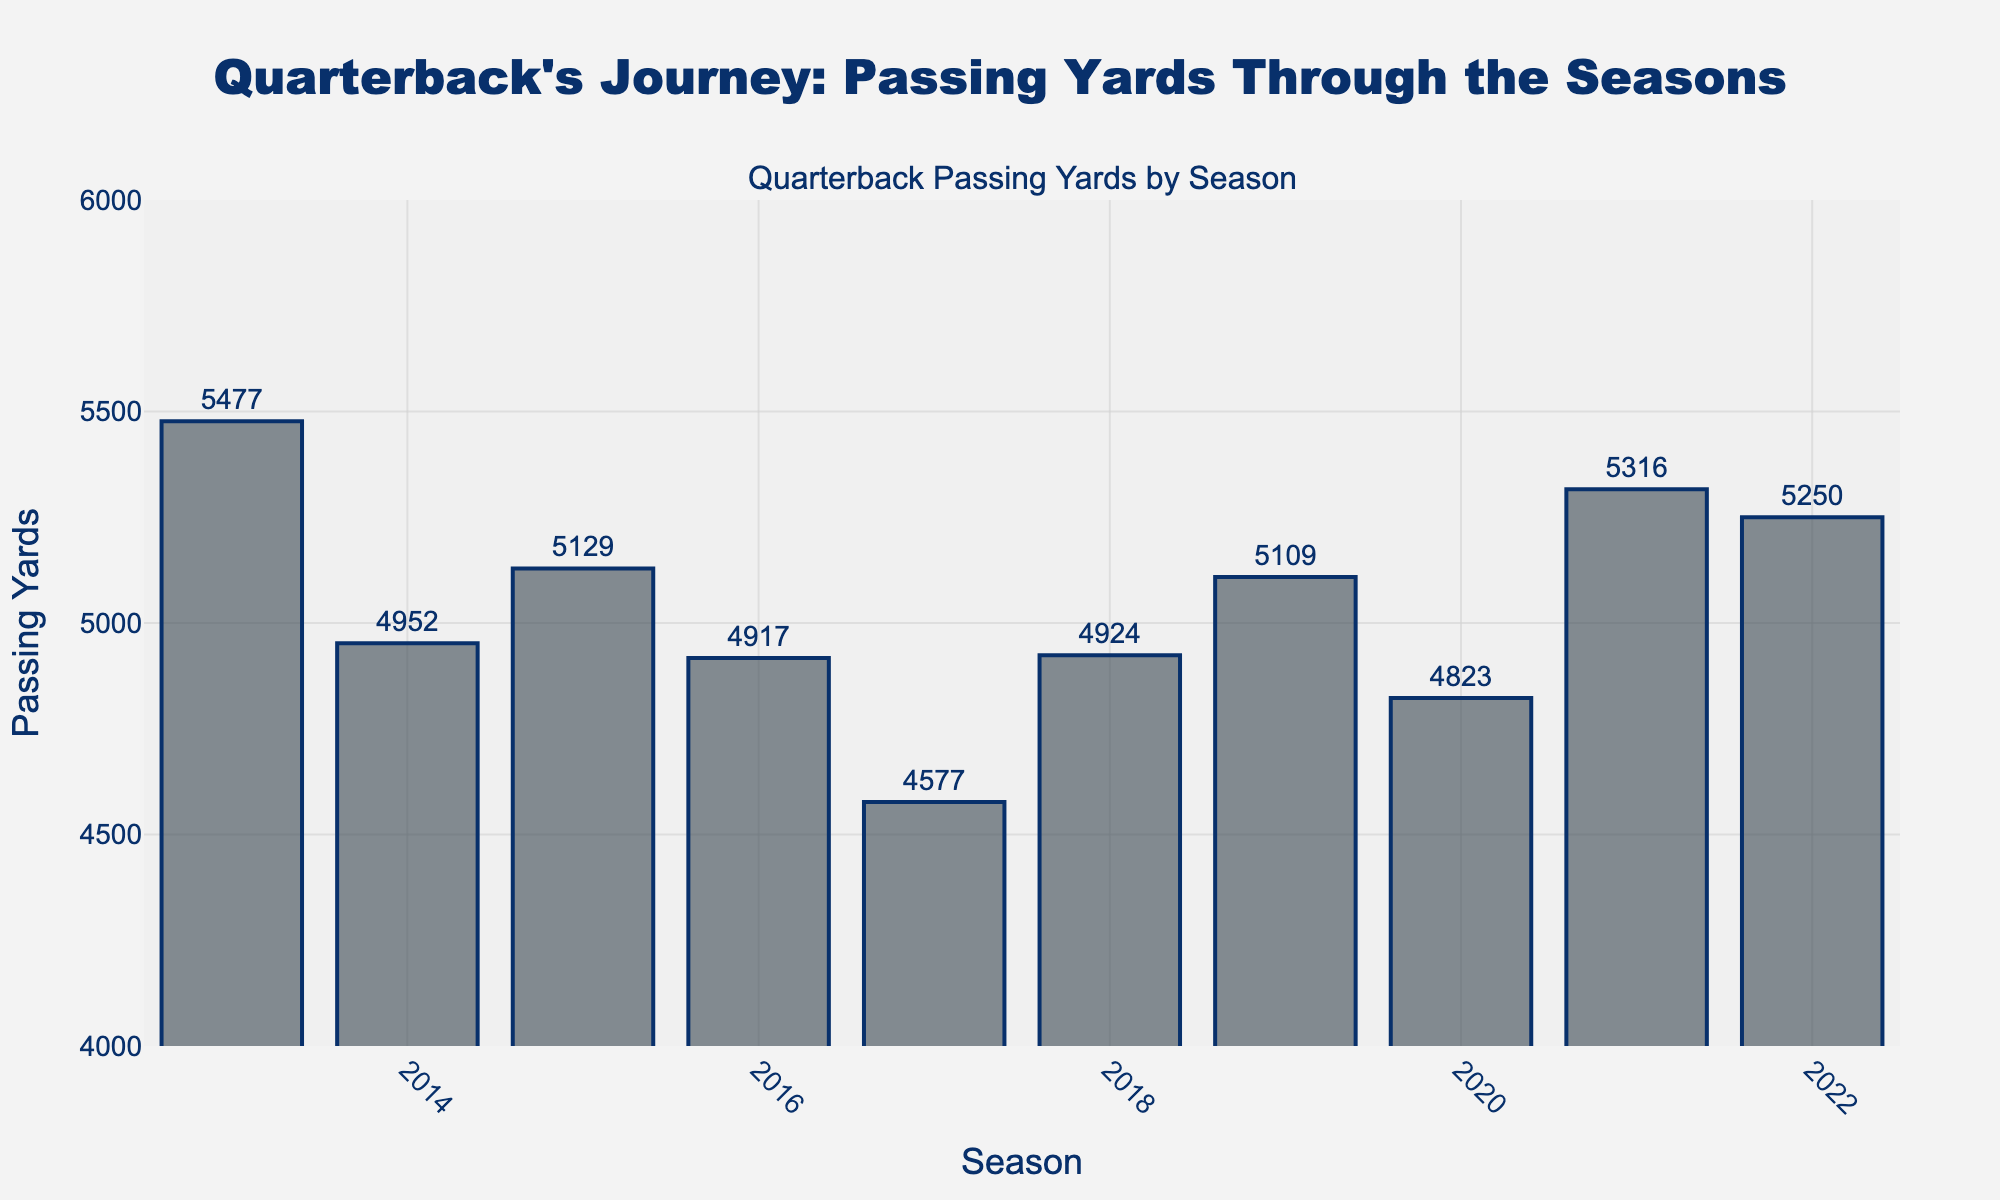Which season had the highest passing yards? The season with the highest passing yards can be identified by finding the tallest bar on the chart. The 2013 season has the highest passing yards, with a value of 5477.
Answer: 2013 How many seasons had passing yards greater than 5000? Count the number of bars whose height corresponds to passing yards greater than 5000. The seasons 2013, 2015, 2019, 2021, and 2022 each have over 5000 passing yards, totaling 5 seasons.
Answer: 5 Which seasons had an increase in passing yards compared to the previous season? Compare the passing yards of each season to the previous season. 2014 to 2015, 2017 to 2018, 2018 to 2019, 2019 to 2021, and 2020 to 2021 show increases in passing yards.
Answer: 2015, 2018, 2019, 2021 How did the passing yards change from 2016 to 2018? To find the change, look at the passing yards for 2016, 2017, and 2018. They are 4917, 4577, and 4924 respectively. From 2016 to 2017, the passing yards decreased by 340 (4917 - 4577). From 2017 to 2018, the passing yards increased by 347 (4924 - 4577).
Answer: Decreased by 340, increased by 347 What was the average passing yards over the last 5 seasons? Sum the passing yards for the seasons 2018, 2019, 2020, 2021, and 2022 and divide by 5. The sum is 4924 + 5109 + 4823 + 5316 + 5250 = 25422, so the average is 25422 / 5 = 5084.4
Answer: 5084.4 Compare the passing yards of the two consecutive highest seasons? The two highest passing seasons are 2013 (5477) and 2021 (5316). The difference in passing yards is 5477 - 5316 = 161.
Answer: 161 Which season had the lowest passing yards, and how much was it? The season with the lowest passing yards is identified by finding the shortest bar on the chart. The 2017 season has the lowest passing yards, with a value of 4577.
Answer: 2017, 4577 What is the range of passing yards over the ten seasons? The range is the difference between the maximum and minimum passing yards. The maximum is 5477 (2013) and the minimum is 4577 (2017), so the range is 5477 - 4577 = 900.
Answer: 900 How do the passing yards in 2014 compare to those in 2020? Look at the heights of the bars for 2014 (4952) and 2020 (4823). The passing yards in 2014 are greater than in 2020 by 4952 - 4823 = 129.
Answer: 129 